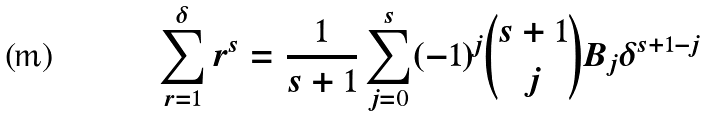<formula> <loc_0><loc_0><loc_500><loc_500>\sum _ { r = 1 } ^ { \delta } r ^ { s } = \frac { 1 } { s + 1 } \sum _ { j = 0 } ^ { s } ( - 1 ) ^ { j } \binom { s + 1 } { j } B _ { j } \delta ^ { s + 1 - j }</formula> 